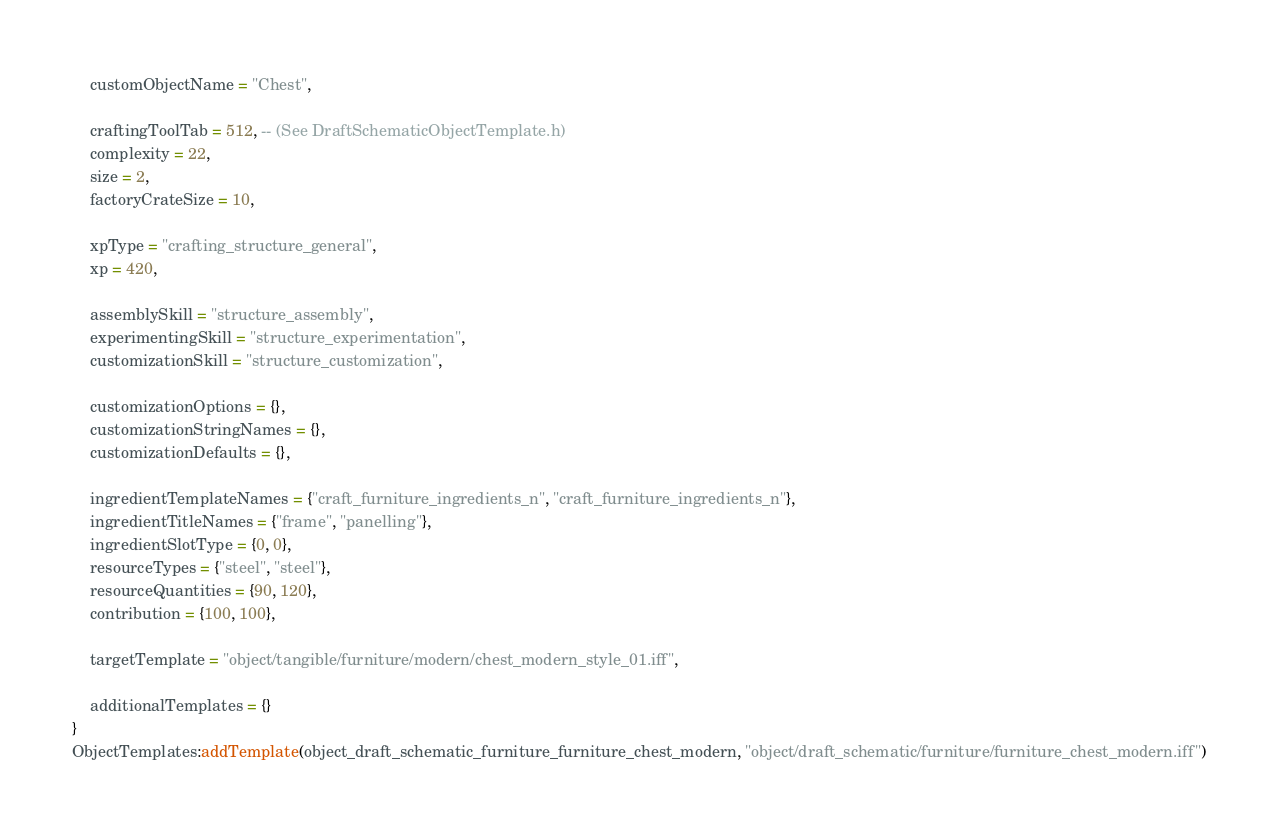<code> <loc_0><loc_0><loc_500><loc_500><_Lua_>	customObjectName = "Chest",

	craftingToolTab = 512, -- (See DraftSchematicObjectTemplate.h)
	complexity = 22,
	size = 2,
	factoryCrateSize = 10,

	xpType = "crafting_structure_general",
	xp = 420,

	assemblySkill = "structure_assembly",
	experimentingSkill = "structure_experimentation",
	customizationSkill = "structure_customization",

	customizationOptions = {},
	customizationStringNames = {},
	customizationDefaults = {},

	ingredientTemplateNames = {"craft_furniture_ingredients_n", "craft_furniture_ingredients_n"},
	ingredientTitleNames = {"frame", "panelling"},
	ingredientSlotType = {0, 0},
	resourceTypes = {"steel", "steel"},
	resourceQuantities = {90, 120},
	contribution = {100, 100},

	targetTemplate = "object/tangible/furniture/modern/chest_modern_style_01.iff",

	additionalTemplates = {}
}
ObjectTemplates:addTemplate(object_draft_schematic_furniture_furniture_chest_modern, "object/draft_schematic/furniture/furniture_chest_modern.iff")
</code> 